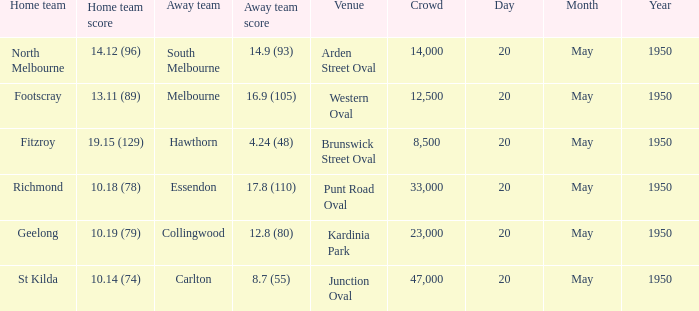Where did the away team score 1 Arden Street Oval. 